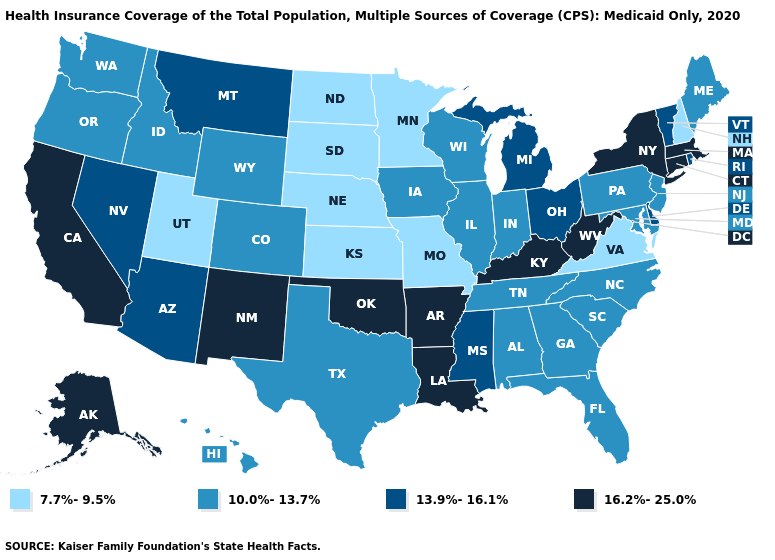What is the value of Utah?
Give a very brief answer. 7.7%-9.5%. Does Virginia have the lowest value in the South?
Be succinct. Yes. Does Missouri have the lowest value in the MidWest?
Short answer required. Yes. What is the lowest value in the USA?
Be succinct. 7.7%-9.5%. What is the lowest value in the South?
Keep it brief. 7.7%-9.5%. How many symbols are there in the legend?
Concise answer only. 4. Name the states that have a value in the range 7.7%-9.5%?
Answer briefly. Kansas, Minnesota, Missouri, Nebraska, New Hampshire, North Dakota, South Dakota, Utah, Virginia. Does Connecticut have the highest value in the Northeast?
Keep it brief. Yes. Name the states that have a value in the range 7.7%-9.5%?
Give a very brief answer. Kansas, Minnesota, Missouri, Nebraska, New Hampshire, North Dakota, South Dakota, Utah, Virginia. What is the highest value in the USA?
Quick response, please. 16.2%-25.0%. What is the highest value in the USA?
Give a very brief answer. 16.2%-25.0%. Which states have the highest value in the USA?
Write a very short answer. Alaska, Arkansas, California, Connecticut, Kentucky, Louisiana, Massachusetts, New Mexico, New York, Oklahoma, West Virginia. Name the states that have a value in the range 7.7%-9.5%?
Answer briefly. Kansas, Minnesota, Missouri, Nebraska, New Hampshire, North Dakota, South Dakota, Utah, Virginia. Name the states that have a value in the range 16.2%-25.0%?
Quick response, please. Alaska, Arkansas, California, Connecticut, Kentucky, Louisiana, Massachusetts, New Mexico, New York, Oklahoma, West Virginia. What is the value of Connecticut?
Quick response, please. 16.2%-25.0%. 